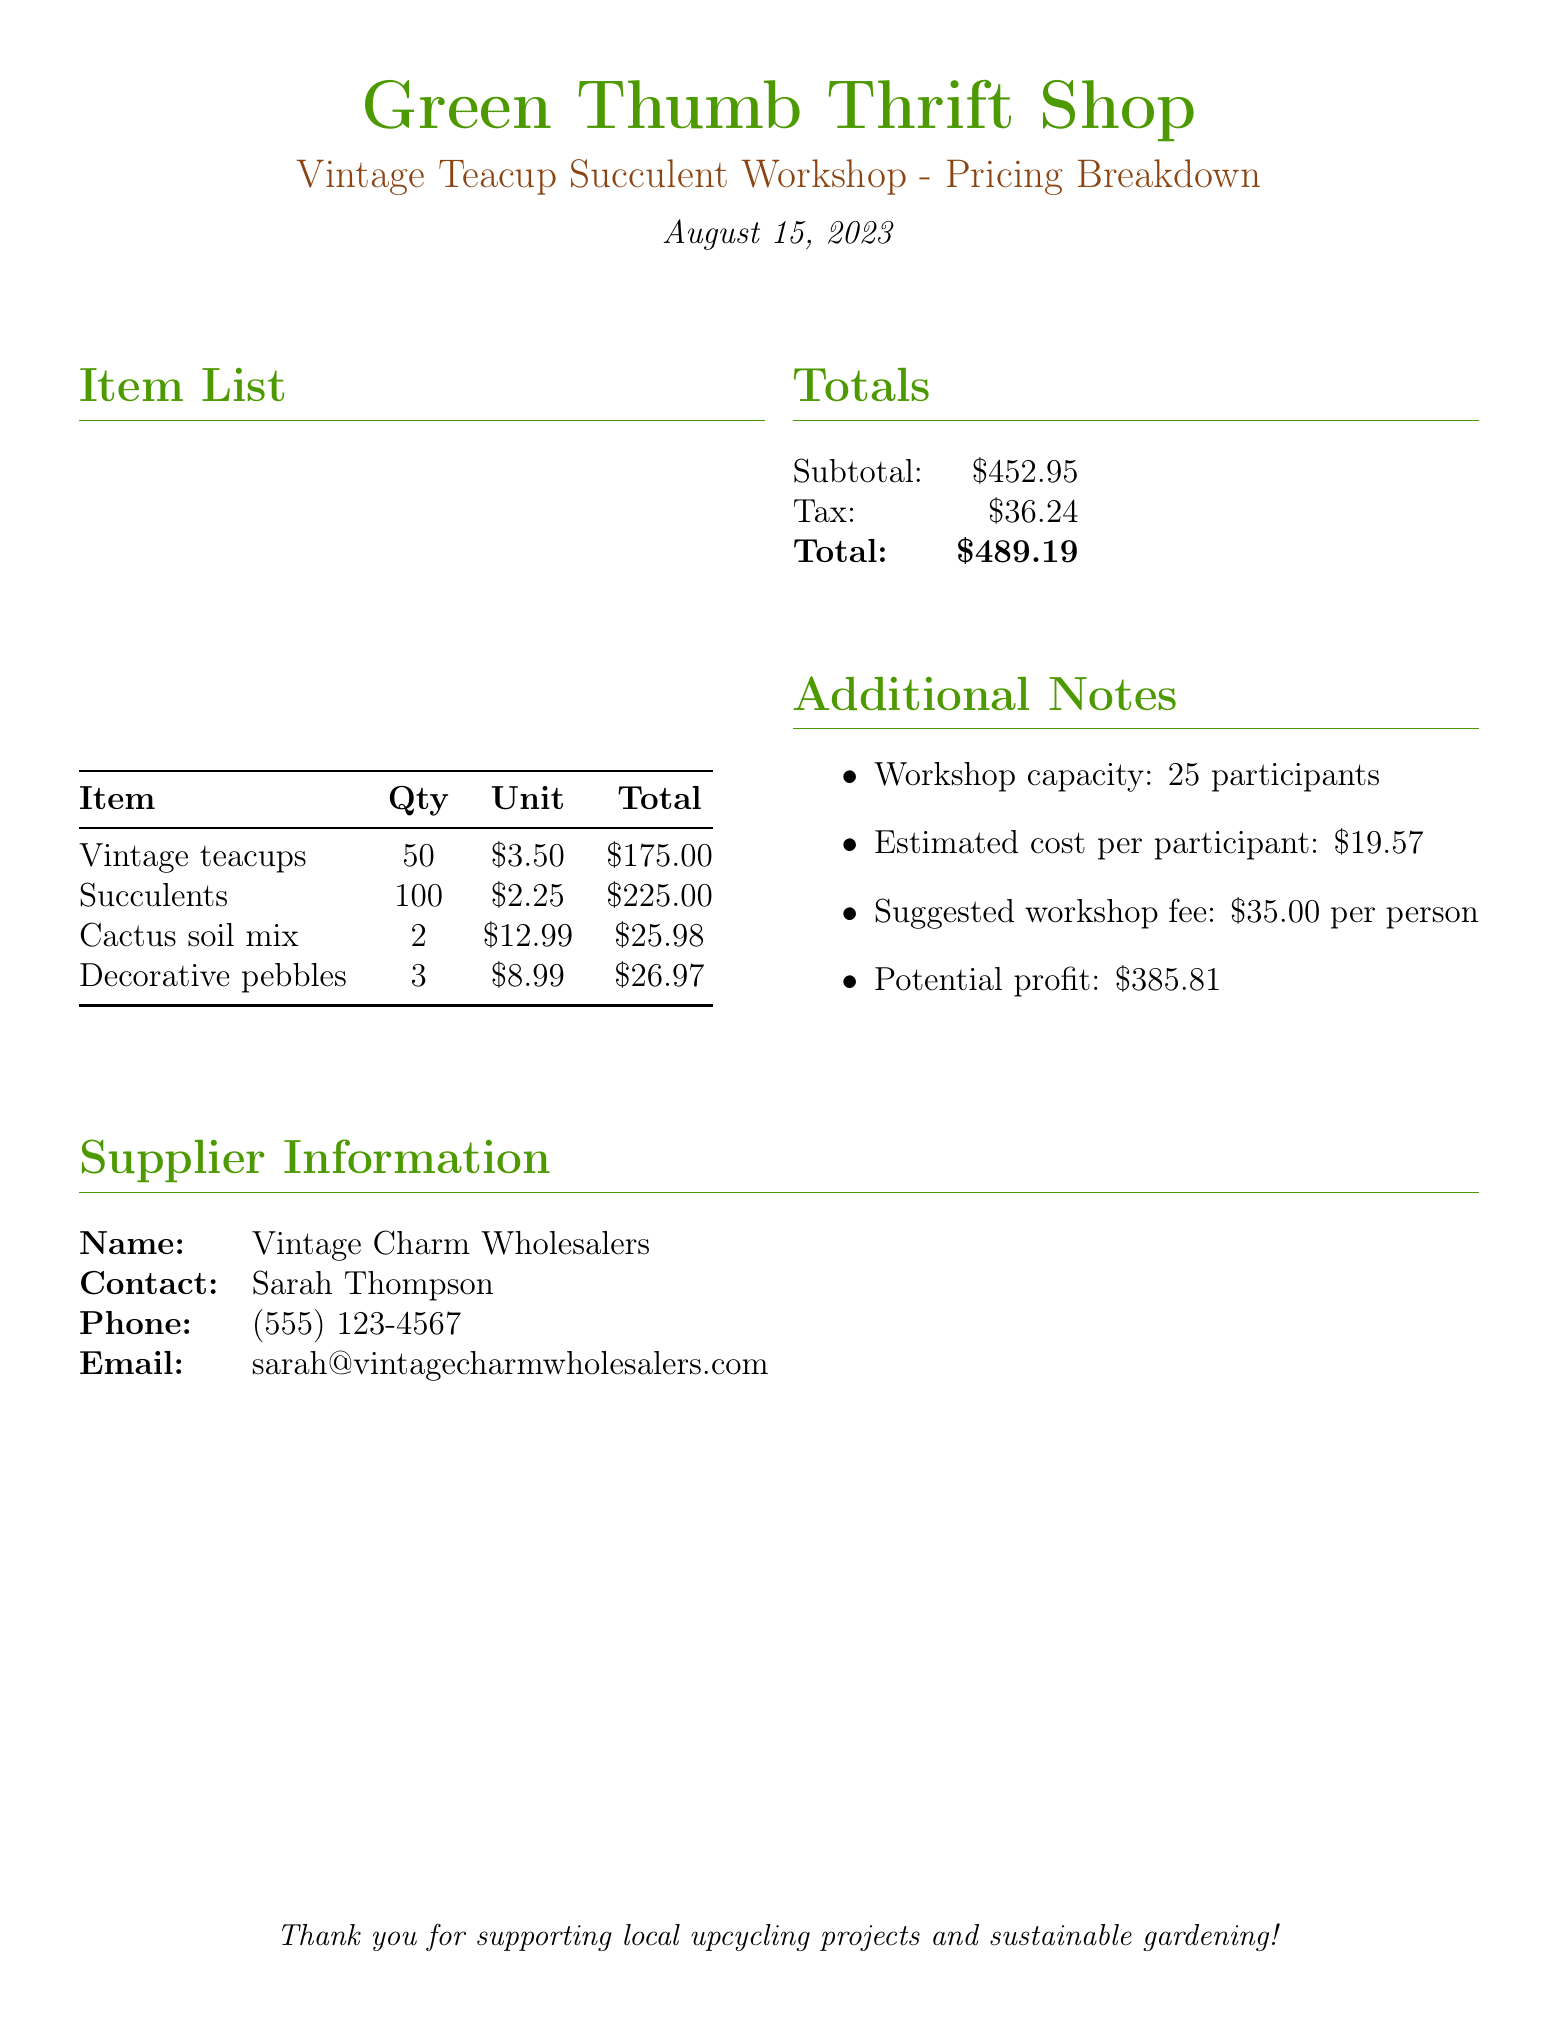What is the total quantity of vintage teacups? The total quantity of vintage teacups is listed in the item list, which is 50.
Answer: 50 What is the total cost for succulents? The total cost for succulents is found in the item list, which shows $225.00.
Answer: $225.00 What is the name of the supplier? The supplier's name is provided in the supplier information section as Vintage Charm Wholesalers.
Answer: Vintage Charm Wholesalers What is the suggested workshop fee per person? The suggested workshop fee per person is stated in the additional notes, which is $35.00.
Answer: $35.00 What is the subtotal before tax? The subtotal before tax is provided in the totals section, which is $452.95.
Answer: $452.95 What is the estimated cost per participant? The estimated cost per participant is listed in the additional notes as $19.57.
Answer: $19.57 What is the total amount including tax? The total amount including tax is specified in the totals section as $489.19.
Answer: $489.19 How many participants can the workshop accommodate? The workshop capacity is mentioned in the additional notes as 25 participants.
Answer: 25 What is the total cost of cactus soil mix? The total cost of cactus soil mix can be found in the item list as $25.98.
Answer: $25.98 